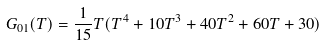Convert formula to latex. <formula><loc_0><loc_0><loc_500><loc_500>G _ { 0 1 } ( T ) = \frac { 1 } { 1 5 } T ( T ^ { 4 } + 1 0 T ^ { 3 } + 4 0 T ^ { 2 } + 6 0 T + 3 0 )</formula> 